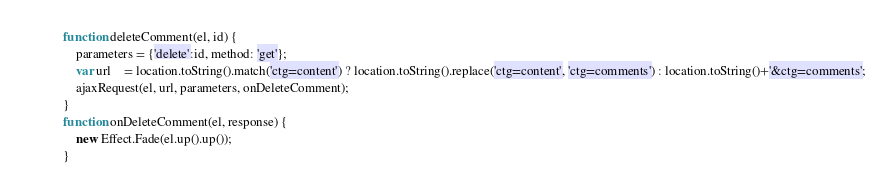Convert code to text. <code><loc_0><loc_0><loc_500><loc_500><_JavaScript_>function deleteComment(el, id) {
	parameters = {'delete':id, method: 'get'};
	var url    = location.toString().match('ctg=content') ? location.toString().replace('ctg=content', 'ctg=comments') : location.toString()+'&ctg=comments';
	ajaxRequest(el, url, parameters, onDeleteComment);	
}
function onDeleteComment(el, response) {
	new Effect.Fade(el.up().up());
}
</code> 